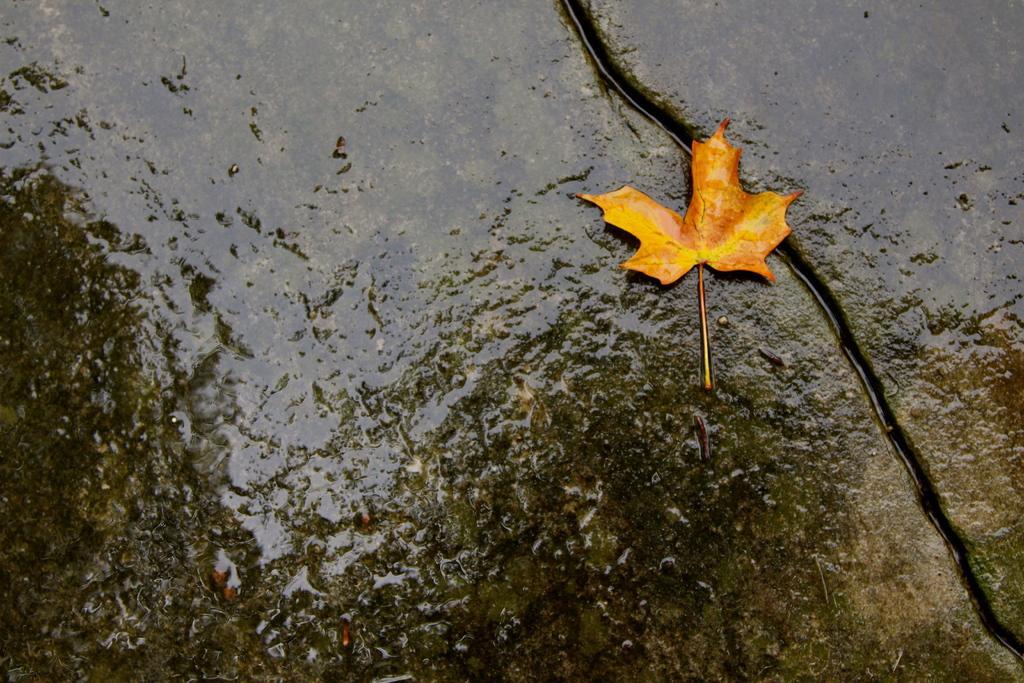Could you give a brief overview of what you see in this image? In this image I can see a rocky surface and on it I can see some water and a leaf which is yellow and orange in color. 